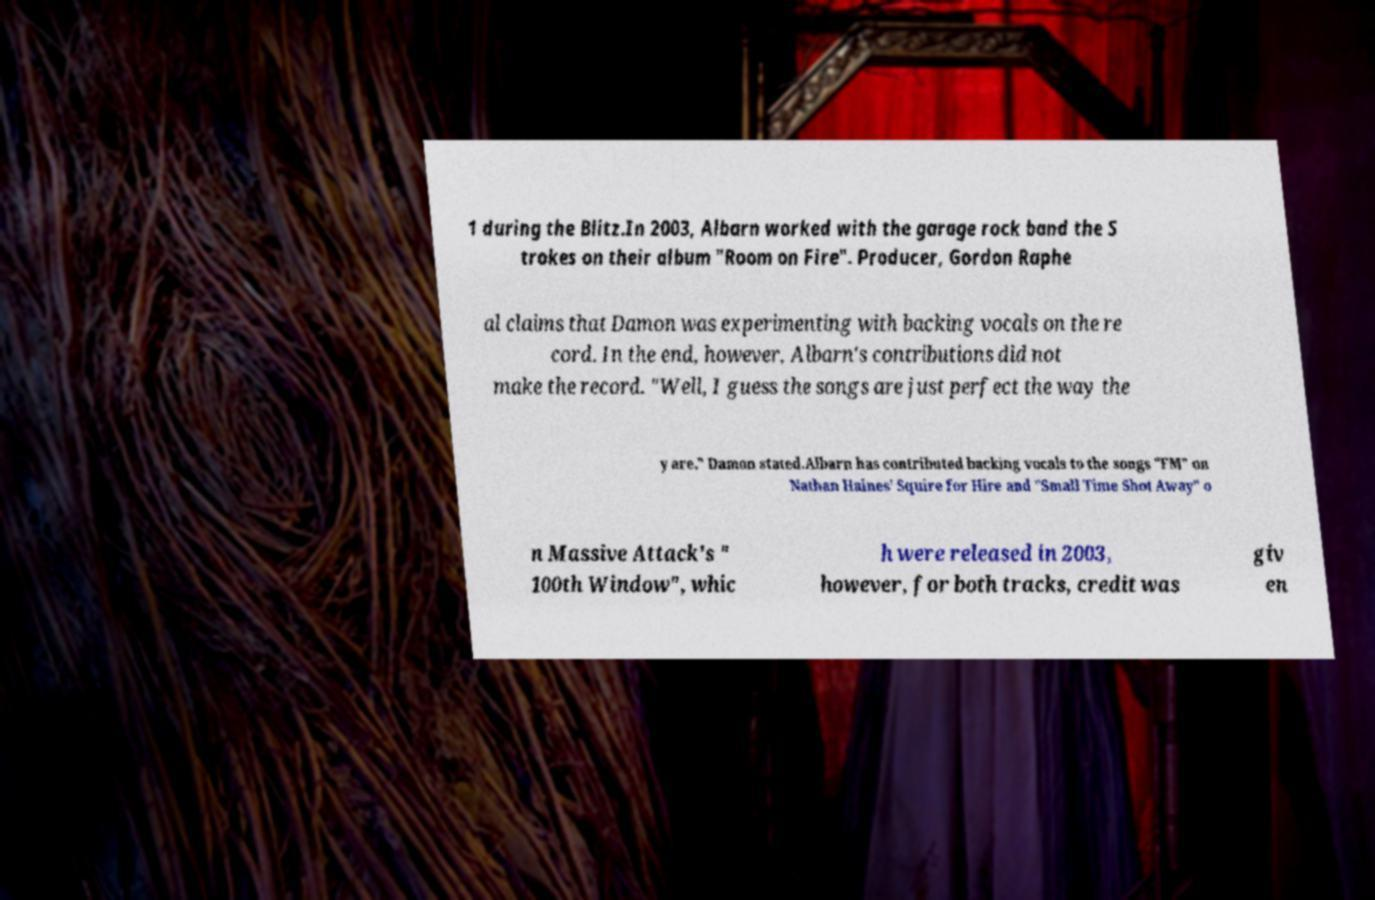For documentation purposes, I need the text within this image transcribed. Could you provide that? 1 during the Blitz.In 2003, Albarn worked with the garage rock band the S trokes on their album "Room on Fire". Producer, Gordon Raphe al claims that Damon was experimenting with backing vocals on the re cord. In the end, however, Albarn's contributions did not make the record. "Well, I guess the songs are just perfect the way the y are," Damon stated.Albarn has contributed backing vocals to the songs "FM" on Nathan Haines' Squire for Hire and "Small Time Shot Away" o n Massive Attack's " 100th Window", whic h were released in 2003, however, for both tracks, credit was giv en 